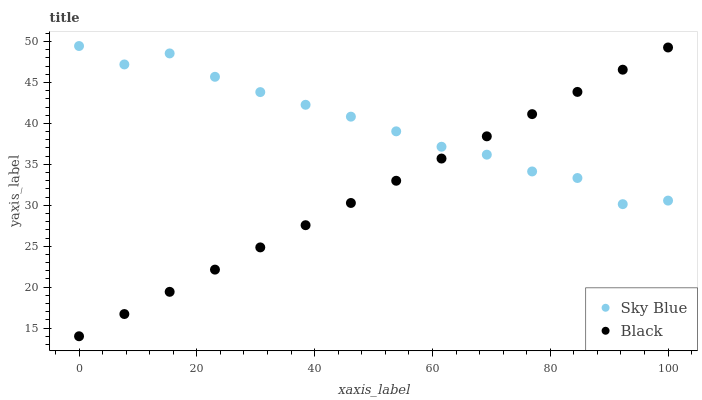Does Black have the minimum area under the curve?
Answer yes or no. Yes. Does Sky Blue have the maximum area under the curve?
Answer yes or no. Yes. Does Black have the maximum area under the curve?
Answer yes or no. No. Is Black the smoothest?
Answer yes or no. Yes. Is Sky Blue the roughest?
Answer yes or no. Yes. Is Black the roughest?
Answer yes or no. No. Does Black have the lowest value?
Answer yes or no. Yes. Does Sky Blue have the highest value?
Answer yes or no. Yes. Does Black have the highest value?
Answer yes or no. No. Does Sky Blue intersect Black?
Answer yes or no. Yes. Is Sky Blue less than Black?
Answer yes or no. No. Is Sky Blue greater than Black?
Answer yes or no. No. 